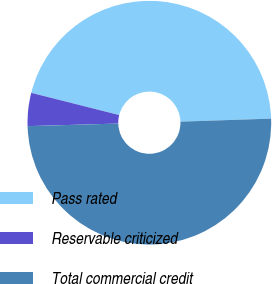Convert chart to OTSL. <chart><loc_0><loc_0><loc_500><loc_500><pie_chart><fcel>Pass rated<fcel>Reservable criticized<fcel>Total commercial credit<nl><fcel>45.53%<fcel>4.39%<fcel>50.08%<nl></chart> 